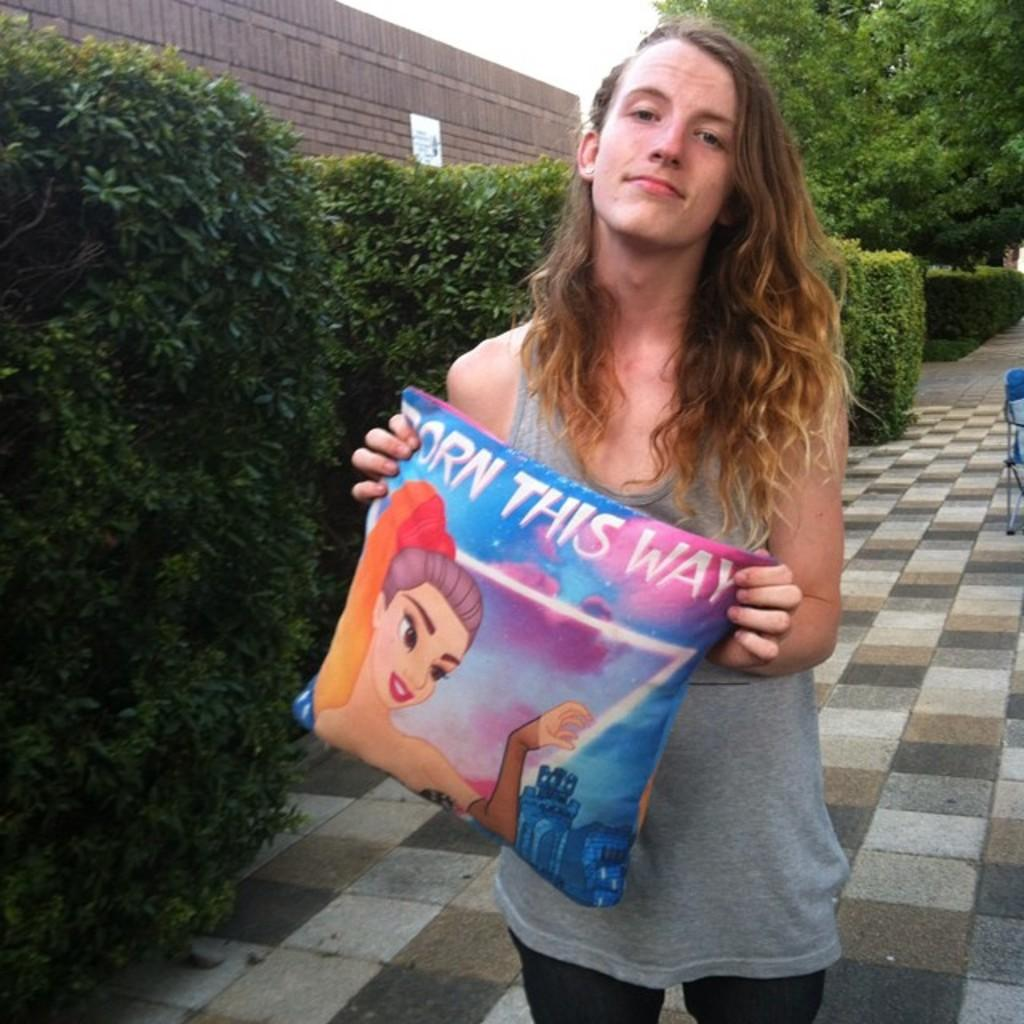Who is present in the image? There is a woman in the image. What is the woman holding in the image? The woman is holding a pillow. What can be seen on the left side of the image? There are many plants on the left side of the image. Where is the woman standing in the image? The woman is standing on a pavement. How does the woman use the faucet in the image? There is no faucet present in the image. 